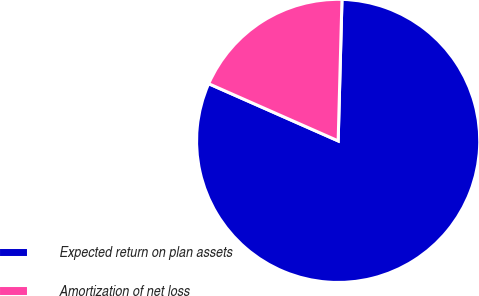Convert chart. <chart><loc_0><loc_0><loc_500><loc_500><pie_chart><fcel>Expected return on plan assets<fcel>Amortization of net loss<nl><fcel>81.19%<fcel>18.81%<nl></chart> 